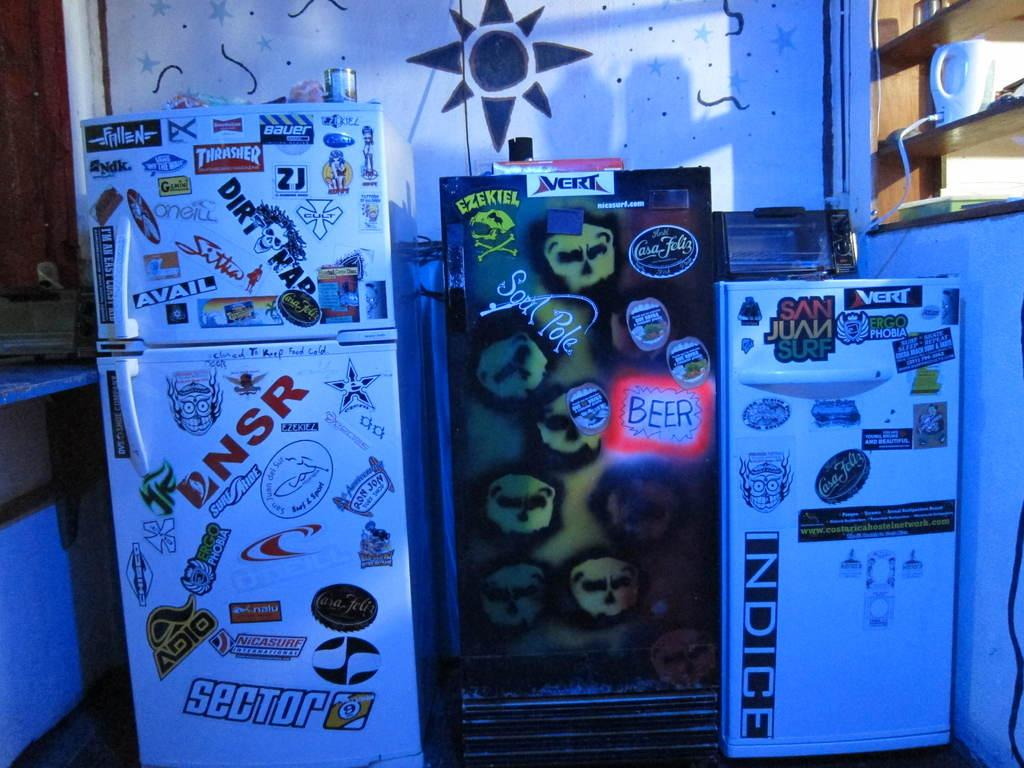<image>
Summarize the visual content of the image. 3 different refrigerators lined up with all kinds of logos stickers on them 